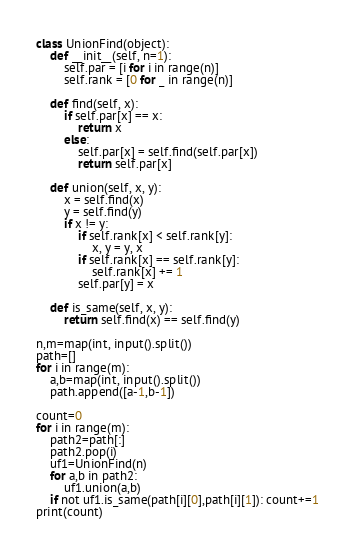<code> <loc_0><loc_0><loc_500><loc_500><_Python_>class UnionFind(object):
    def __init__(self, n=1):
        self.par = [i for i in range(n)]
        self.rank = [0 for _ in range(n)]

    def find(self, x):
        if self.par[x] == x:
            return x
        else:
            self.par[x] = self.find(self.par[x])
            return self.par[x]

    def union(self, x, y):
        x = self.find(x)
        y = self.find(y)
        if x != y:
            if self.rank[x] < self.rank[y]:
                x, y = y, x
            if self.rank[x] == self.rank[y]:
                self.rank[x] += 1
            self.par[y] = x

    def is_same(self, x, y):
        return self.find(x) == self.find(y)
      
n,m=map(int, input().split())
path=[]
for i in range(m):
    a,b=map(int, input().split())
    path.append([a-1,b-1])
    
count=0
for i in range(m):
    path2=path[:]
    path2.pop(i)
    uf1=UnionFind(n)
    for a,b in path2:
        uf1.union(a,b)
    if not uf1.is_same(path[i][0],path[i][1]): count+=1
print(count)</code> 